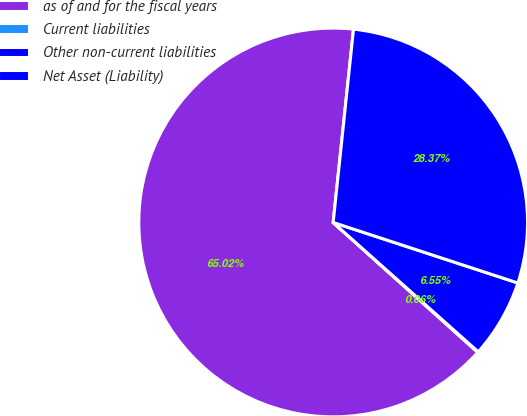Convert chart to OTSL. <chart><loc_0><loc_0><loc_500><loc_500><pie_chart><fcel>as of and for the fiscal years<fcel>Current liabilities<fcel>Other non-current liabilities<fcel>Net Asset (Liability)<nl><fcel>65.02%<fcel>0.06%<fcel>6.55%<fcel>28.37%<nl></chart> 